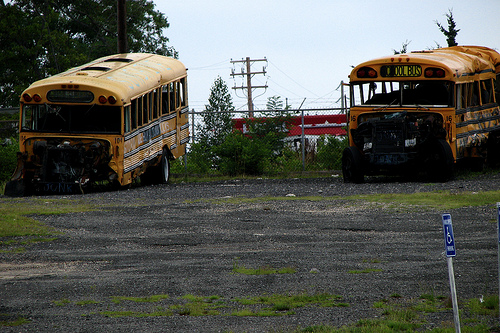Which kind of vehicle is broken? The broken vehicle in the image is a bus, which can be identified by its damaged front section and its overall aged appearance. 